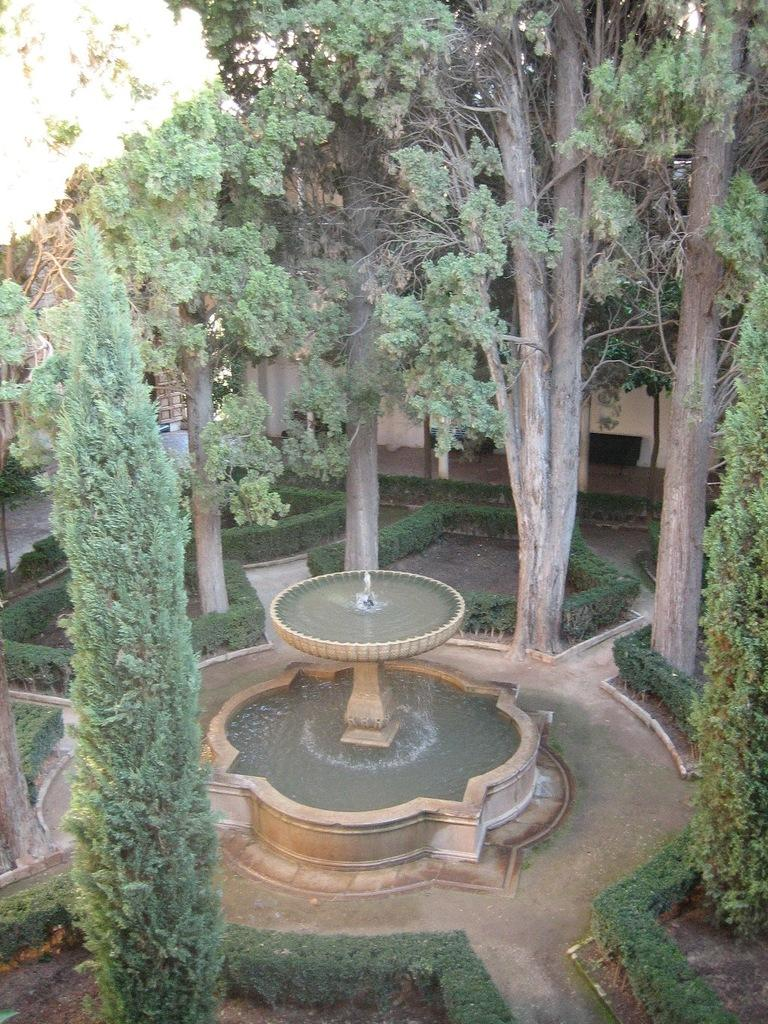What type of vegetation can be seen in the image? There are trees and plants in the image. What is the purpose of the water fountain in the image? The water fountain in the image is likely for decoration or as a source of water for the plants. What is visible in the background of the image? There is a wall in the background of the image. What is the weight of the root system of the trees in the image? There is no information about the weight of the root system of the trees in the image, as it is not visible or mentioned in the provided facts. 